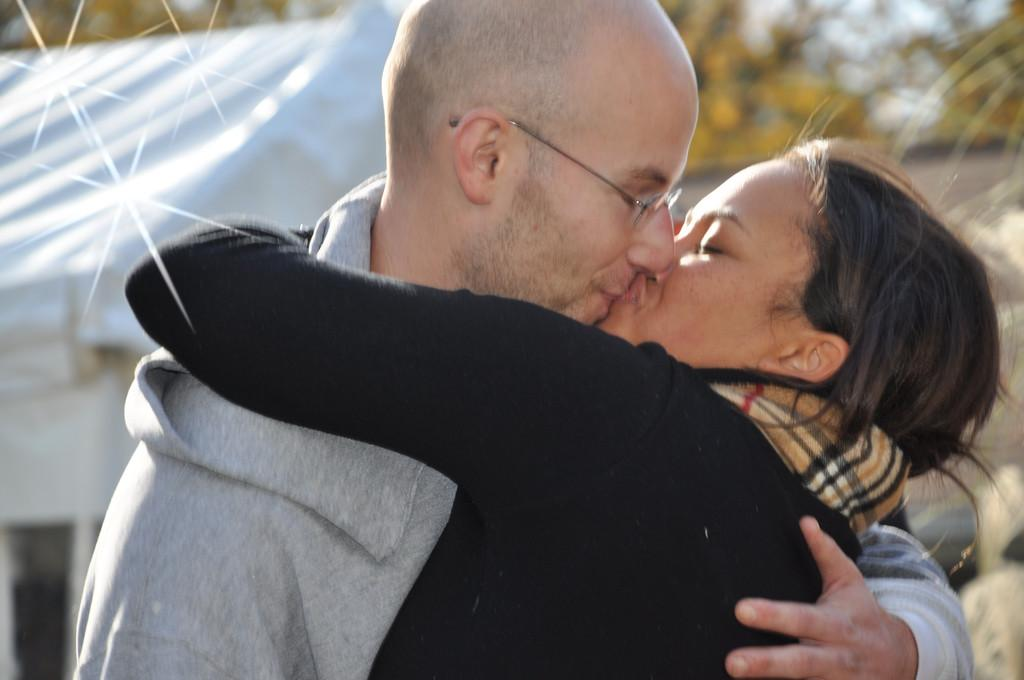How many people are in the image? There is a woman and a man in the image. What are the woman and man doing in the image? The woman and man are kissing and hugging each other. What can be seen in the background of the image? The background of the image appears blurry, and there is a tent and trees visible. What type of alarm can be heard going off in the image? There is no alarm present in the image, and therefore no such sound can be heard. 